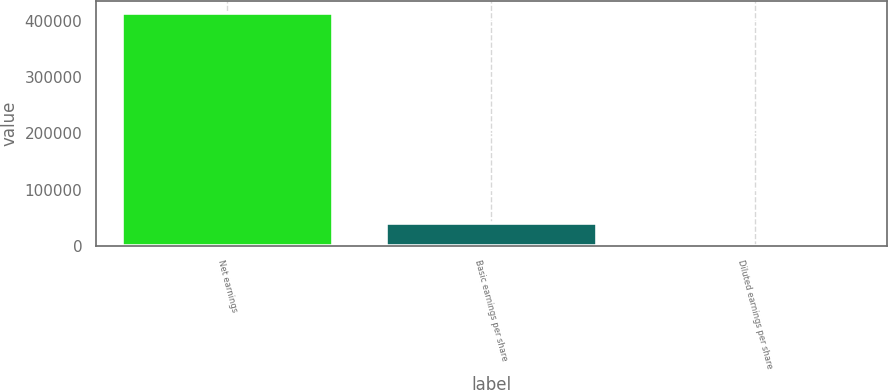Convert chart. <chart><loc_0><loc_0><loc_500><loc_500><bar_chart><fcel>Net earnings<fcel>Basic earnings per share<fcel>Diluted earnings per share<nl><fcel>414421<fcel>41447.6<fcel>6.13<nl></chart> 